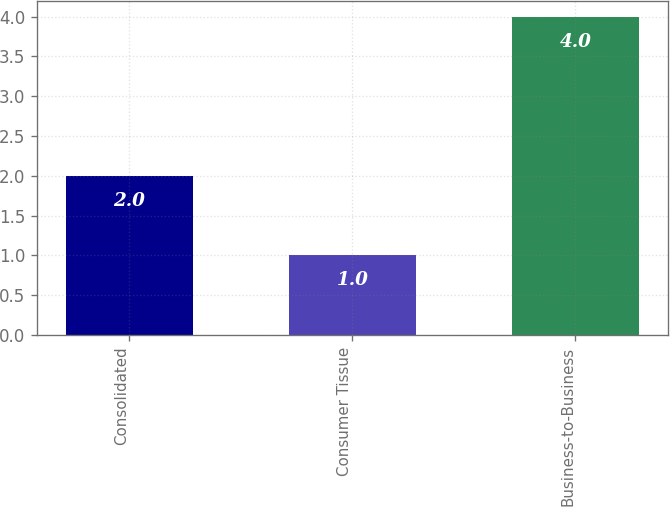<chart> <loc_0><loc_0><loc_500><loc_500><bar_chart><fcel>Consolidated<fcel>Consumer Tissue<fcel>Business-to-Business<nl><fcel>2<fcel>1<fcel>4<nl></chart> 